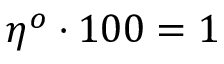Convert formula to latex. <formula><loc_0><loc_0><loc_500><loc_500>\eta ^ { o } \cdot 1 0 0 = 1 \</formula> 